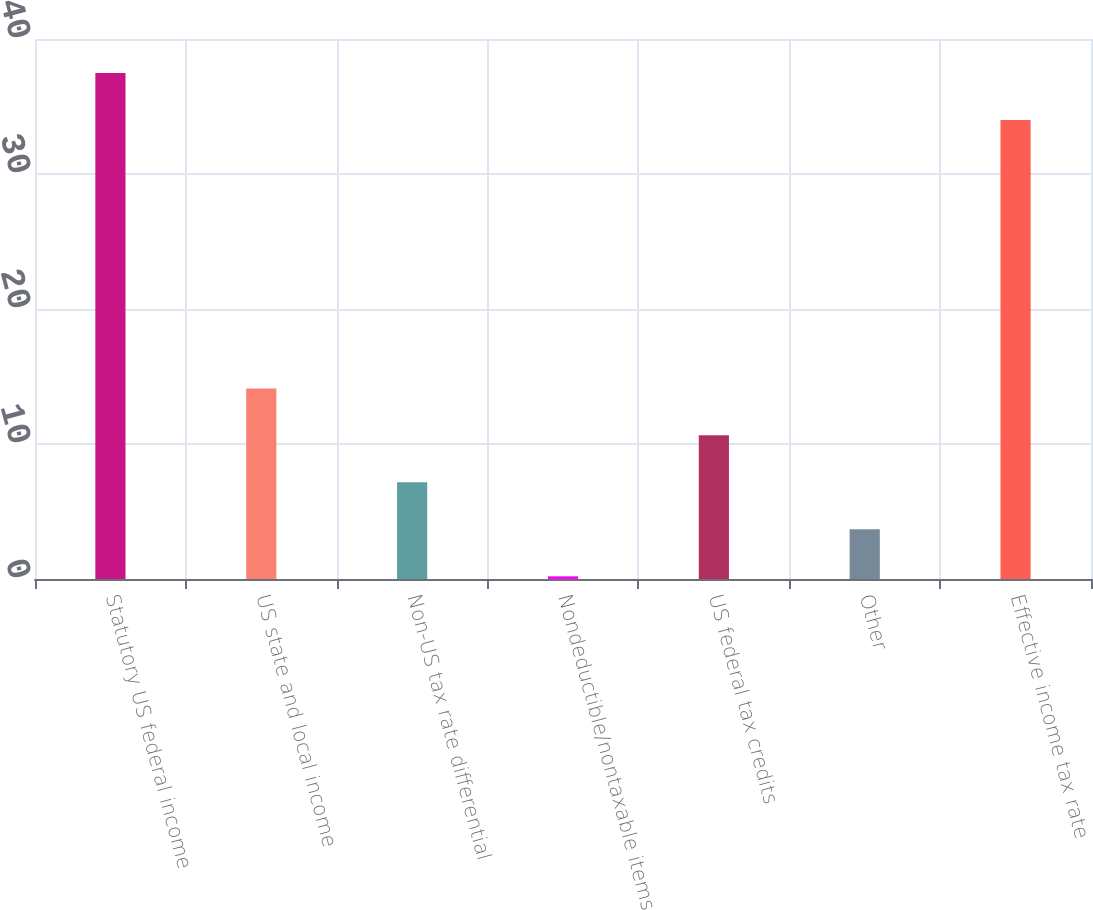Convert chart to OTSL. <chart><loc_0><loc_0><loc_500><loc_500><bar_chart><fcel>Statutory US federal income<fcel>US state and local income<fcel>Non-US tax rate differential<fcel>Nondeductible/nontaxable items<fcel>US federal tax credits<fcel>Other<fcel>Effective income tax rate<nl><fcel>37.48<fcel>14.12<fcel>7.16<fcel>0.2<fcel>10.64<fcel>3.68<fcel>34<nl></chart> 